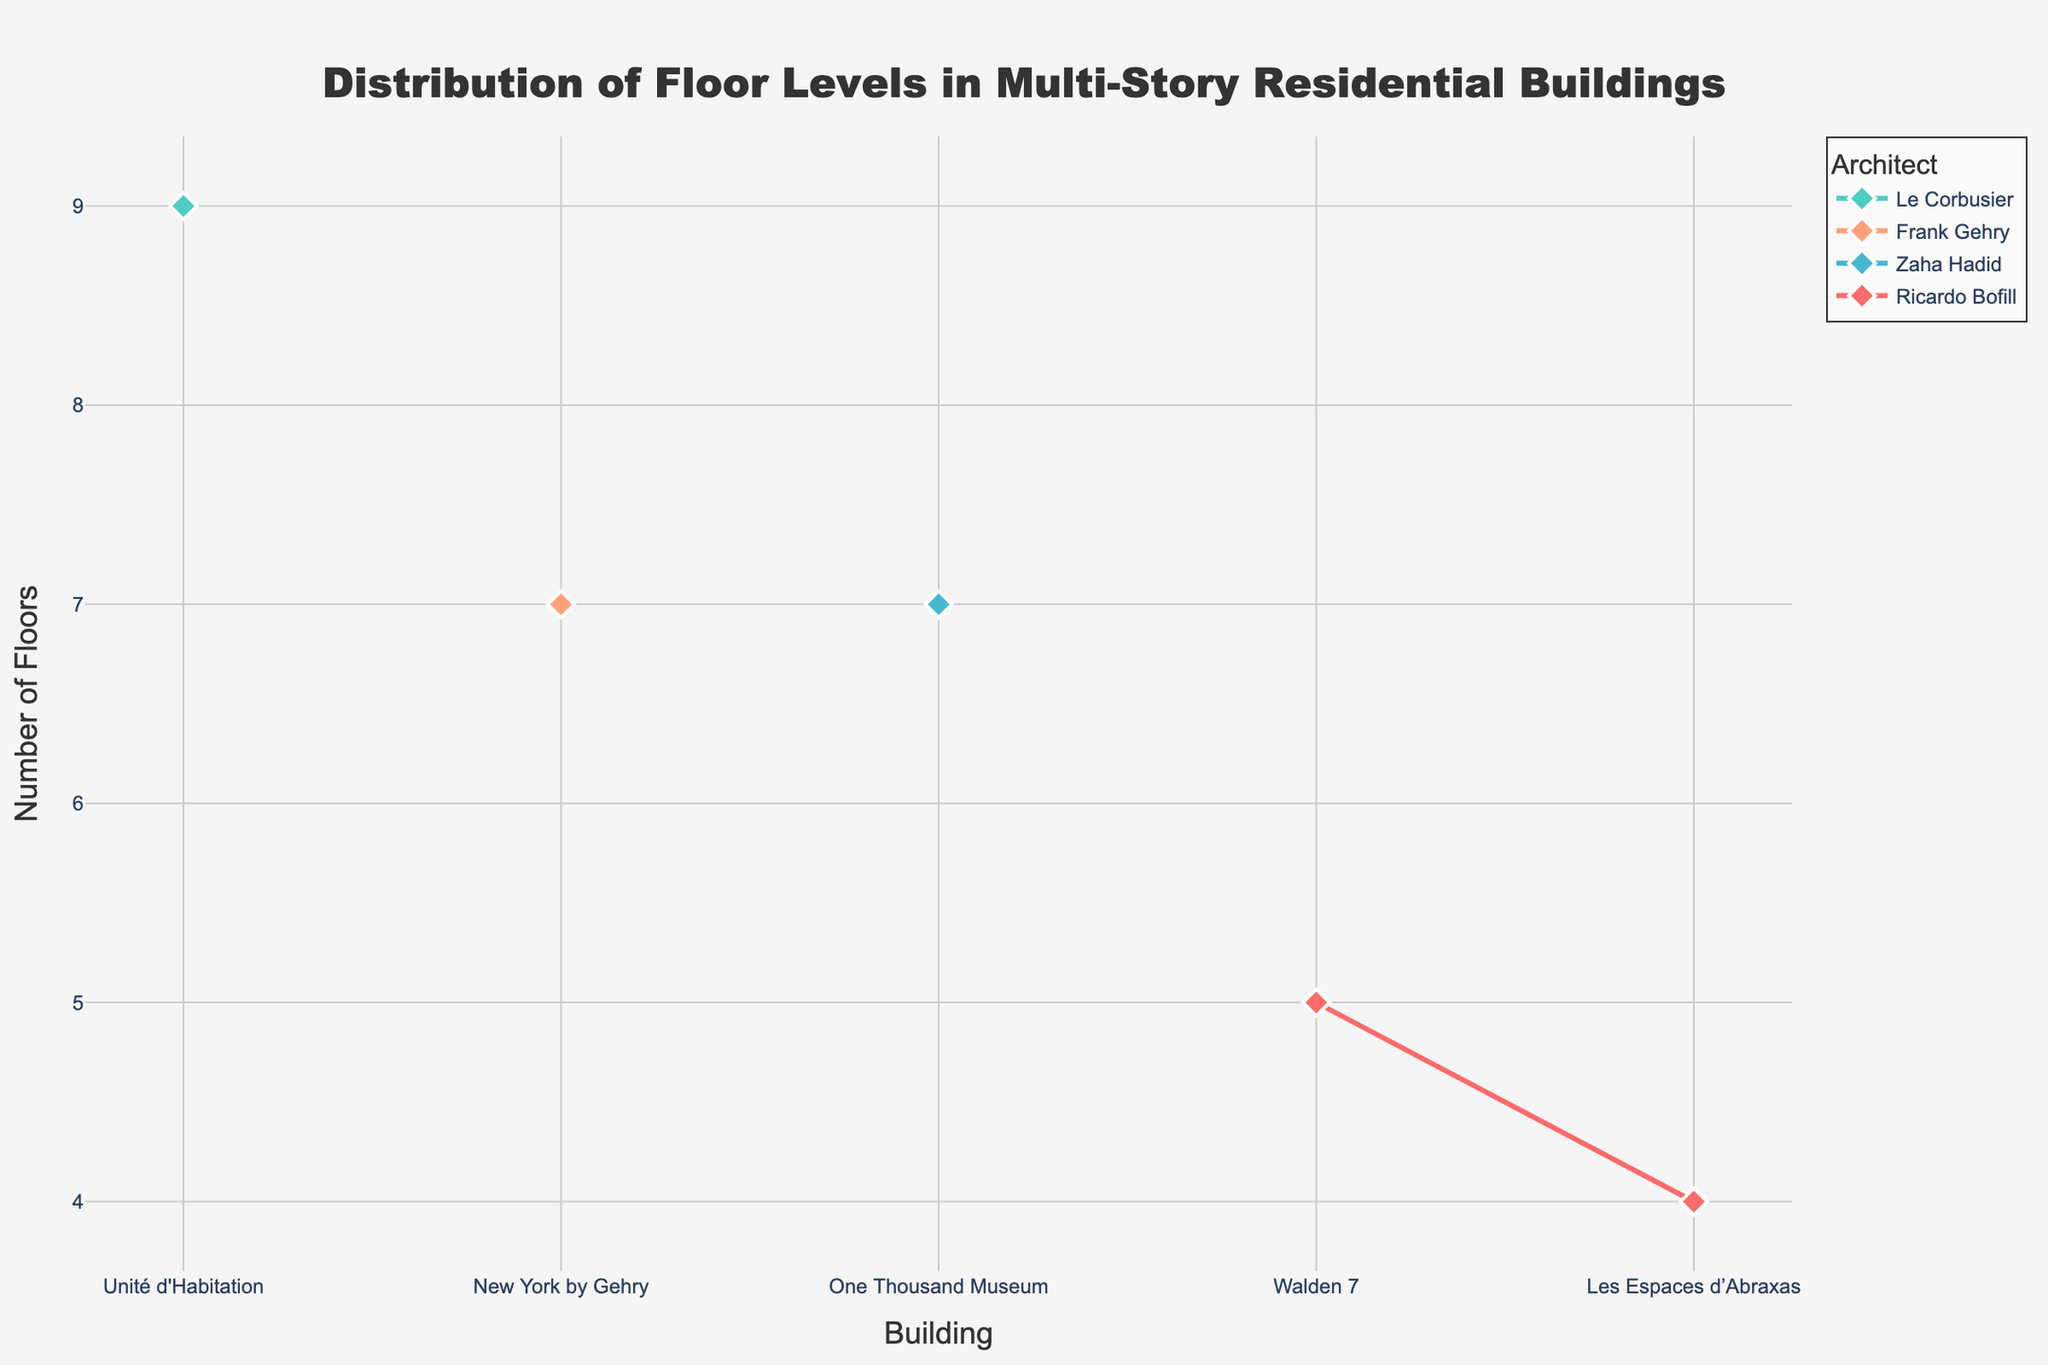How many buildings did Ricardo Bofill design in the plot? There are two unique buildings listed under Ricardo Bofill: "Les Espaces d’Abraxas" and "Walden 7".
Answer: 2 Which building has the highest number of floors in the plot? "Unité d'Habitation" by Le Corbusier has 9 floors, which is the highest among the listed buildings.
Answer: Unité d'Habitation How many more floors does "Unité d'Habitation" have compared to "Les Espaces d’Abraxas"? "Unité d'Habitation" has 9 floors, while "Les Espaces d’Abraxas" has 4 floors. The difference is 9 - 4 = 5 floors.
Answer: 5 floors Which architect has the greatest range of floor levels across their buildings? Ricardo Bofill's buildings range from 1 to 5 floors, Le Corbusier's from 1 to 9, Zaha Hadid's from 1 to 7, and Frank Gehry's from 1 to 7. Le Corbusier has the greatest range of 9 floors.
Answer: Le Corbusier What is the average number of floors for the buildings designed by Zaha Hadid? Zaha Hadid's "One Thousand Museum" has floor levels from 1 to 7, so the average number of floors is (1+2+3+4+5+6+7)/7 = 4 floors.
Answer: 4 floors Which buildings share the same maximum number of floors? "New York by Gehry" by Frank Gehry and "One Thousand Museum" by Zaha Hadid both have a maximum of 7 floors.
Answer: New York by Gehry, One Thousand Museum Which architect has only one building represented in this figure? Both Zaha Hadid and Frank Gehry are listed with only one building each: "One Thousand Museum" and "New York by Gehry," respectively.
Answer: Zaha Hadid, Frank Gehry Is the range of floors larger in Ricardo Bofill's designed buildings or in Le Corbusier's buildings? Ricardo Bofill's buildings range from 1 to 5 floors (a range of 5-1=4), while Le Corbusier's range from 1 to 9 floors (a range of 9-1=8). Therefore, the range of floors in Le Corbusier's buildings is larger.
Answer: Le Corbusier 